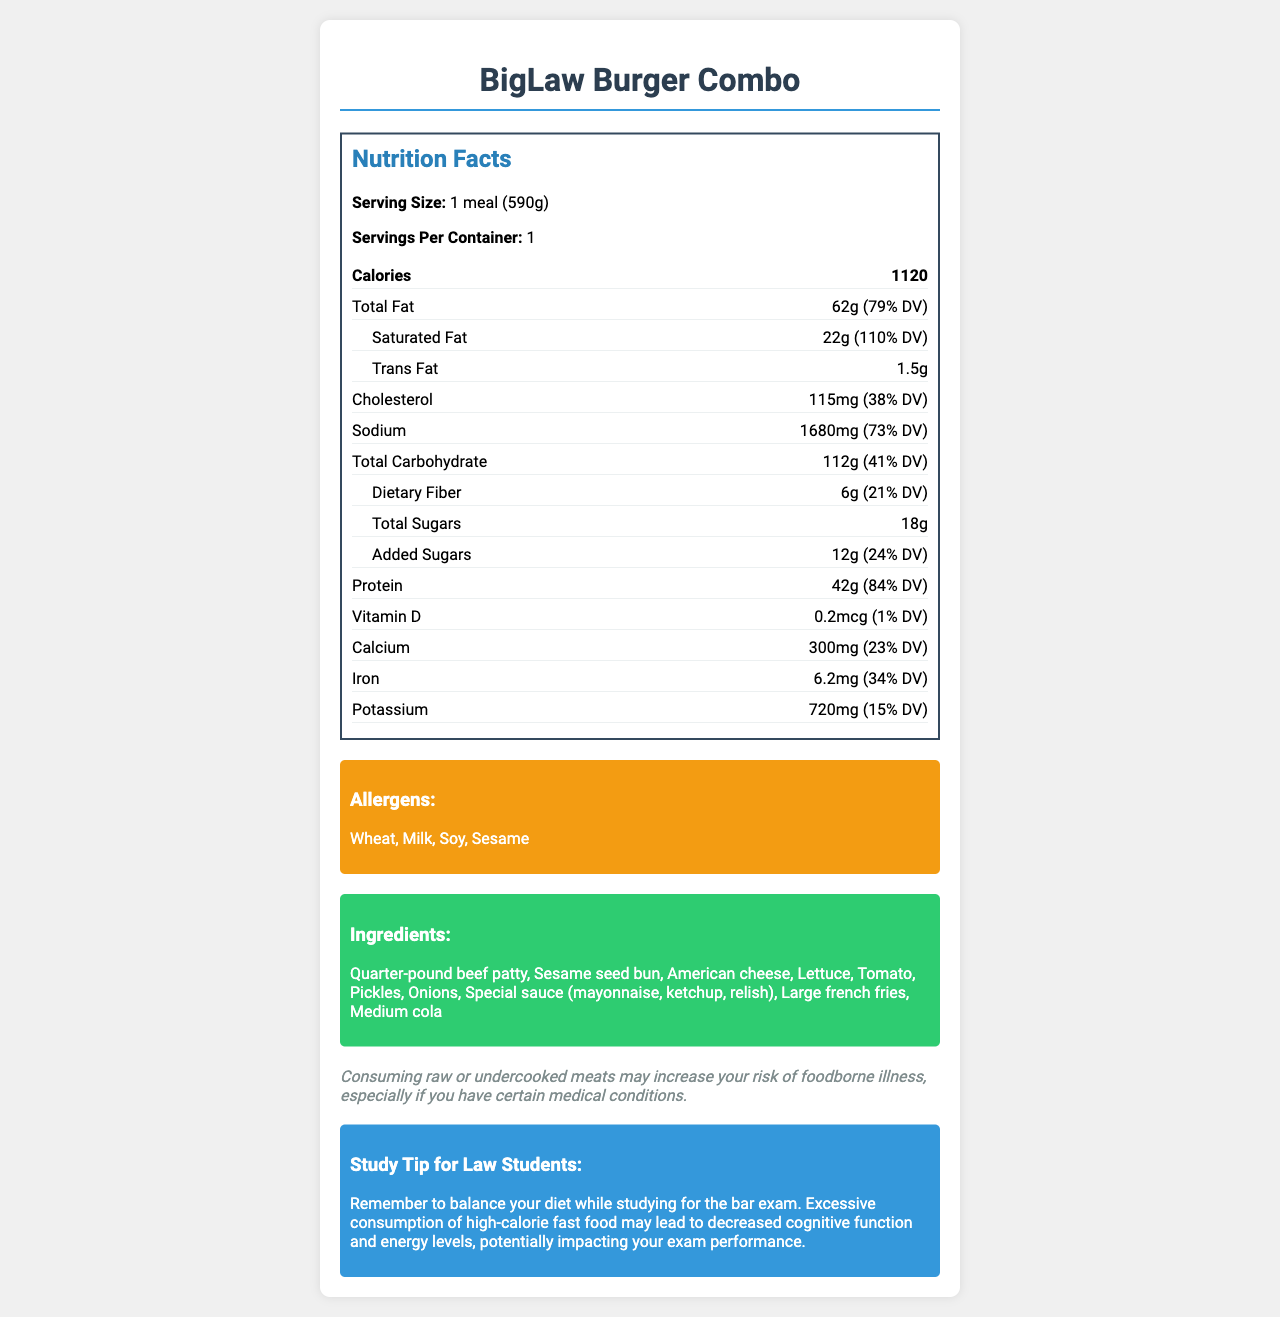what is the serving size? The serving size is clearly listed under the Nutrition Facts section as "1 meal (590g)."
Answer: 1 meal (590g) what are the allergens present in the BigLaw Burger Combo? The allergens are listed under a section titled "Allergens" in the document.
Answer: Wheat, Milk, Soy, Sesame how many grams of protein are in the BigLaw Burger Combo? The protein amount is specified under the Nutrition Facts as 42 grams with an 84% daily value.
Answer: 42g what is the total carbohydrate content? The total carbohydrate amount is listed as 112g with a 41% daily value in the Nutrition Facts section.
Answer: 112g how much vitamin D is in the meal? The amount of vitamin D is stated as 0.2 mcg with a daily value of 1%.
Answer: 0.2 mcg which of the following is NOT an ingredient in the BigLaw Burger Combo? A. Quarter-pound beef patty B. Chicken breast C. Sesame seed bun D. Medium cola The listed ingredients include a quarter-pound beef patty, sesame seed bun, and medium cola but do not include chicken breast.
Answer: B how many calories does the BigLaw Burger Combo contain? The total calories are listed in the Nutrition Facts section as 1120.
Answer: 1120 calories is the sodium content of the BigLaw Burger Combo high? The sodium content is 1680 mg, which is 73% of the daily value, indicating a high sodium content.
Answer: Yes what is the main idea of the document? The document details the nutritional information, potential allergens, ingredients, and includes a legal note and a study tip relevant to law students.
Answer: The document provides the nutritional facts, allergens, ingredients, and a legal and study tip for the BigLaw Burger Combo. how much of the daily value of saturated fat is in the BigLaw Burger Combo? The saturated fat content is 22g, which is 110% of the daily value according to the Nutrition Facts.
Answer: 110% what is the study tip given in the document? The study tip advises balancing your diet to avoid decreased cognitive function and energy levels, which could impact exam performance.
Answer: Balance your diet while studying for the bar exam to avoid decreased cognitive function and energy levels. what is the product name? The product name is prominently displayed at the top of the document as "BigLaw Burger Combo."
Answer: BigLaw Burger Combo total fat content in the meal is approximately what percentage of the daily value? The total fat content is 62g, which is 79% of the daily value as shown in the Nutrition Facts.
Answer: 79% which ingredient might increase the risk of foodborne illness if not properly cooked? The legal note mentions that consuming raw or undercooked meats may increase the risk of foodborne illness, applicable to the beef patty.
Answer: Quarter-pound beef patty how many grams of cholesterol are in the BigLaw Burger Combo? The amount of cholesterol is listed as 115mg with a 38% daily value.
Answer: 115mg is dietary fiber content listed? The dietary fiber content is listed as 6g with a 21% daily value.
Answer: Yes what percentage of the daily value of calcium is in the meal? The calcium content is 300mg, which is 23% of the daily value.
Answer: 23% what is the total sugar content of the meal, and how much of it is added sugars? A. 6g, 6g B. 12g, 18g C. 18g, 12g D. 18g, 6g The total sugar content is 18g, with 12g of it being added sugars, as detailed in the Nutrition Facts.
Answer: C how many servings are in a container? The number of servings per container is listed as 1.
Answer: 1 serving what is the total fiber content and what percentage of the daily value does it account for? The dietary fiber content is 6g, accounting for 21% of the daily value.
Answer: 6g, 21% what is the iron content, and is it high compared to daily value percentages? The iron content is 6.2mg, which is 34% of the daily value, indicating a reasonably high percentage.
Answer: 6.2 mg, 34% how many large french fries are included in the BigLaw Burger Combo? The document lists "Large french fries" as an ingredient, but it does not specify the quantity.
Answer: Cannot be determined 